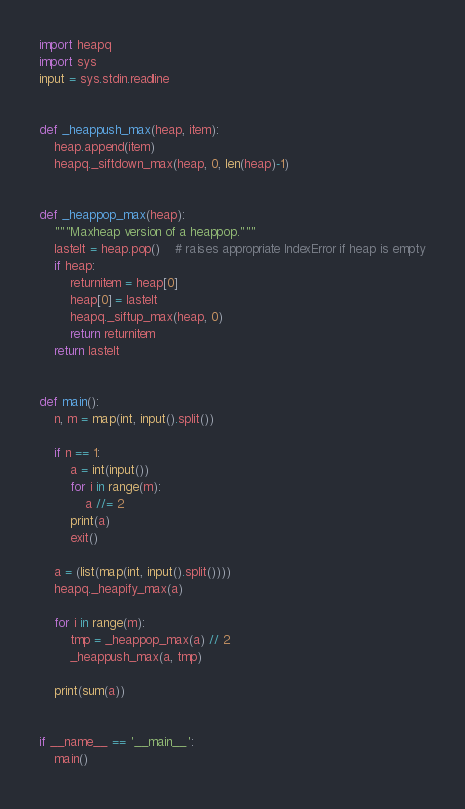<code> <loc_0><loc_0><loc_500><loc_500><_Python_>import heapq
import sys
input = sys.stdin.readline


def _heappush_max(heap, item):
    heap.append(item)
    heapq._siftdown_max(heap, 0, len(heap)-1)


def _heappop_max(heap):
    """Maxheap version of a heappop."""
    lastelt = heap.pop()    # raises appropriate IndexError if heap is empty
    if heap:
        returnitem = heap[0]
        heap[0] = lastelt
        heapq._siftup_max(heap, 0)
        return returnitem
    return lastelt


def main():
    n, m = map(int, input().split())

    if n == 1:
        a = int(input())
        for i in range(m):
            a //= 2
        print(a)
        exit()

    a = (list(map(int, input().split())))
    heapq._heapify_max(a)

    for i in range(m):
        tmp = _heappop_max(a) // 2
        _heappush_max(a, tmp)

    print(sum(a))


if __name__ == '__main__':
    main()
</code> 